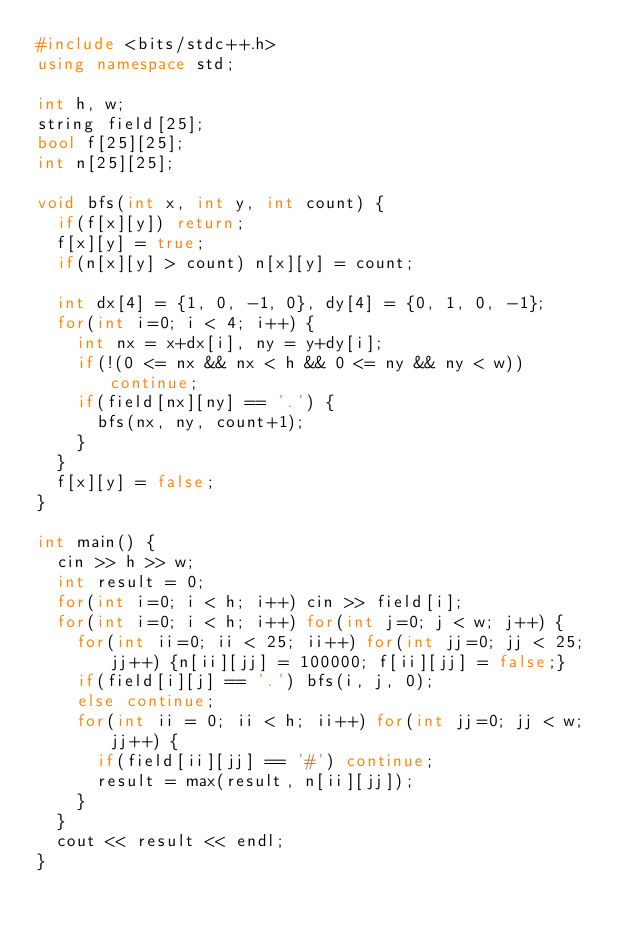Convert code to text. <code><loc_0><loc_0><loc_500><loc_500><_C++_>#include <bits/stdc++.h>
using namespace std;

int h, w;
string field[25];
bool f[25][25];
int n[25][25];

void bfs(int x, int y, int count) {
  if(f[x][y]) return;
  f[x][y] = true;
  if(n[x][y] > count) n[x][y] = count;

  int dx[4] = {1, 0, -1, 0}, dy[4] = {0, 1, 0, -1};
  for(int i=0; i < 4; i++) {
    int nx = x+dx[i], ny = y+dy[i];
    if(!(0 <= nx && nx < h && 0 <= ny && ny < w)) continue;
    if(field[nx][ny] == '.') {
      bfs(nx, ny, count+1);
    }
  }
  f[x][y] = false;
}

int main() {
  cin >> h >> w;
  int result = 0;
  for(int i=0; i < h; i++) cin >> field[i];
  for(int i=0; i < h; i++) for(int j=0; j < w; j++) {
    for(int ii=0; ii < 25; ii++) for(int jj=0; jj < 25; jj++) {n[ii][jj] = 100000; f[ii][jj] = false;}
    if(field[i][j] == '.') bfs(i, j, 0);
    else continue;
    for(int ii = 0; ii < h; ii++) for(int jj=0; jj < w; jj++) {
      if(field[ii][jj] == '#') continue;
      result = max(result, n[ii][jj]);
    }
  }
  cout << result << endl;
}
</code> 